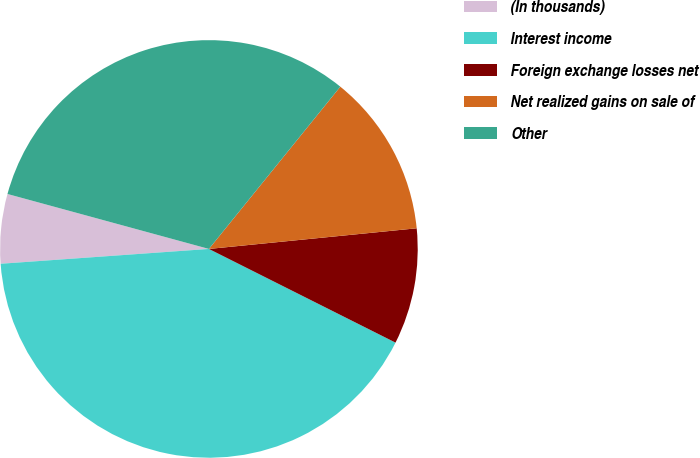Convert chart to OTSL. <chart><loc_0><loc_0><loc_500><loc_500><pie_chart><fcel>(In thousands)<fcel>Interest income<fcel>Foreign exchange losses net<fcel>Net realized gains on sale of<fcel>Other<nl><fcel>5.37%<fcel>41.46%<fcel>8.98%<fcel>12.59%<fcel>31.59%<nl></chart> 